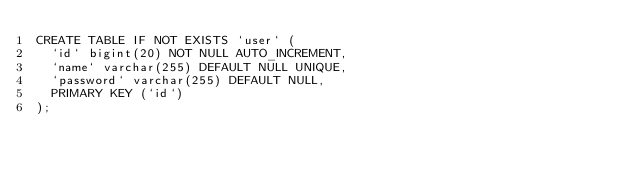<code> <loc_0><loc_0><loc_500><loc_500><_SQL_>CREATE TABLE IF NOT EXISTS `user` (
  `id` bigint(20) NOT NULL AUTO_INCREMENT,
  `name` varchar(255) DEFAULT NULL UNIQUE,
  `password` varchar(255) DEFAULT NULL,
  PRIMARY KEY (`id`)
);
</code> 